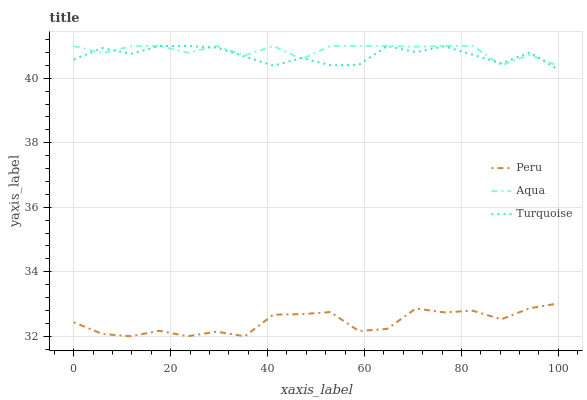Does Peru have the minimum area under the curve?
Answer yes or no. Yes. Does Aqua have the maximum area under the curve?
Answer yes or no. Yes. Does Aqua have the minimum area under the curve?
Answer yes or no. No. Does Peru have the maximum area under the curve?
Answer yes or no. No. Is Turquoise the smoothest?
Answer yes or no. Yes. Is Peru the roughest?
Answer yes or no. Yes. Is Aqua the smoothest?
Answer yes or no. No. Is Aqua the roughest?
Answer yes or no. No. Does Peru have the lowest value?
Answer yes or no. Yes. Does Aqua have the lowest value?
Answer yes or no. No. Does Aqua have the highest value?
Answer yes or no. Yes. Does Peru have the highest value?
Answer yes or no. No. Is Peru less than Turquoise?
Answer yes or no. Yes. Is Turquoise greater than Peru?
Answer yes or no. Yes. Does Aqua intersect Turquoise?
Answer yes or no. Yes. Is Aqua less than Turquoise?
Answer yes or no. No. Is Aqua greater than Turquoise?
Answer yes or no. No. Does Peru intersect Turquoise?
Answer yes or no. No. 